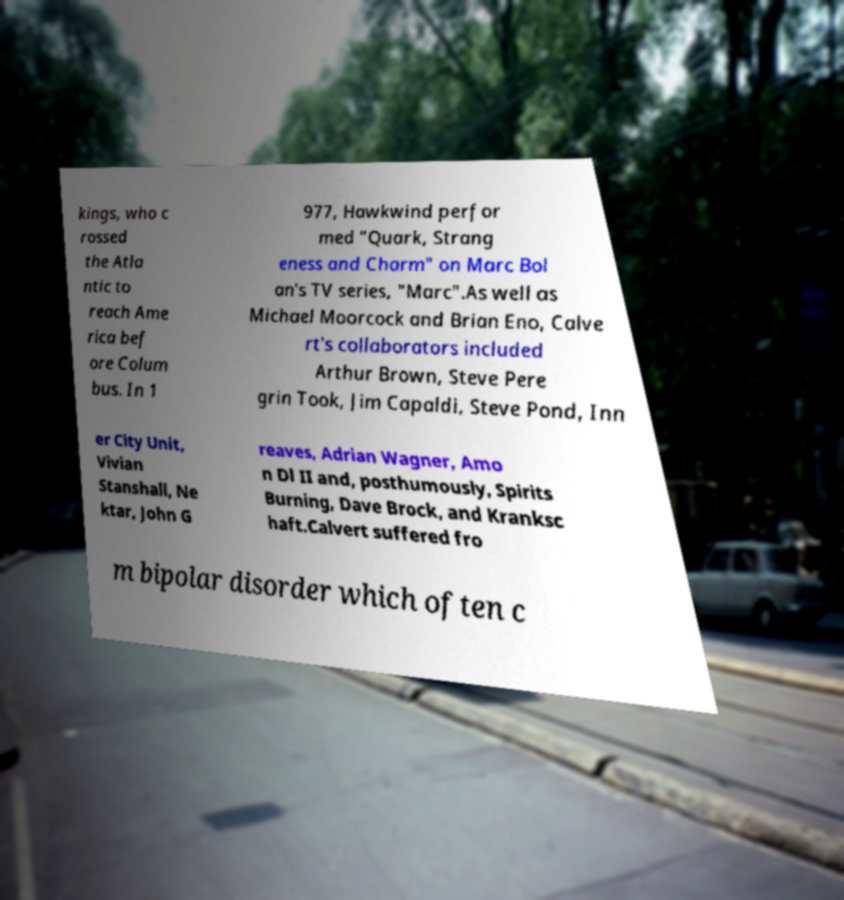There's text embedded in this image that I need extracted. Can you transcribe it verbatim? kings, who c rossed the Atla ntic to reach Ame rica bef ore Colum bus. In 1 977, Hawkwind perfor med "Quark, Strang eness and Charm" on Marc Bol an's TV series, "Marc".As well as Michael Moorcock and Brian Eno, Calve rt's collaborators included Arthur Brown, Steve Pere grin Took, Jim Capaldi, Steve Pond, Inn er City Unit, Vivian Stanshall, Ne ktar, John G reaves, Adrian Wagner, Amo n Dl II and, posthumously, Spirits Burning, Dave Brock, and Kranksc haft.Calvert suffered fro m bipolar disorder which often c 